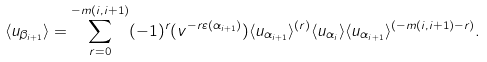Convert formula to latex. <formula><loc_0><loc_0><loc_500><loc_500>\langle u _ { \beta _ { i + 1 } } \rangle = \sum _ { r = 0 } ^ { - m ( i , i + 1 ) } ( - 1 ) ^ { r } ( v ^ { - r \varepsilon ( \alpha _ { i + 1 } ) } ) \langle u _ { \alpha _ { i + 1 } } \rangle ^ { ( r ) } \langle u _ { \alpha _ { i } } \rangle \langle u _ { \alpha _ { i + 1 } } \rangle ^ { ( - m ( i , i + 1 ) - r ) } .</formula> 